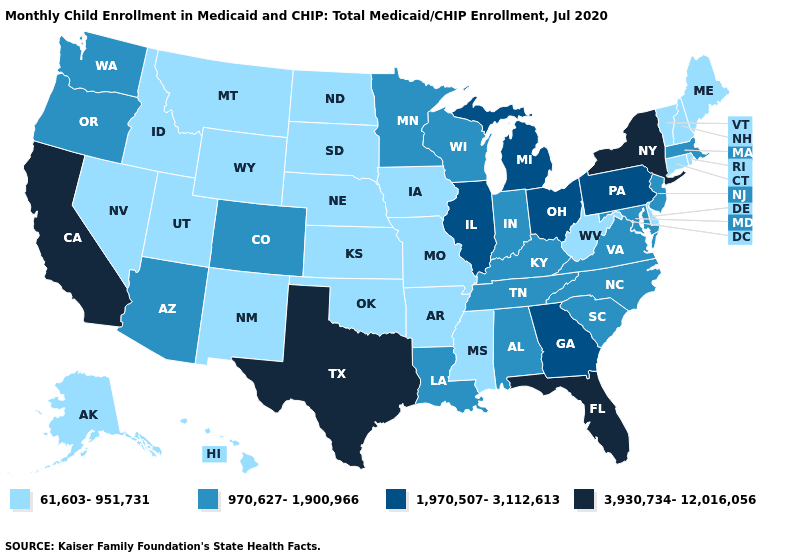What is the highest value in the USA?
Concise answer only. 3,930,734-12,016,056. What is the highest value in states that border West Virginia?
Answer briefly. 1,970,507-3,112,613. What is the value of Georgia?
Concise answer only. 1,970,507-3,112,613. What is the value of Wyoming?
Write a very short answer. 61,603-951,731. Does New Mexico have the lowest value in the USA?
Concise answer only. Yes. Name the states that have a value in the range 61,603-951,731?
Short answer required. Alaska, Arkansas, Connecticut, Delaware, Hawaii, Idaho, Iowa, Kansas, Maine, Mississippi, Missouri, Montana, Nebraska, Nevada, New Hampshire, New Mexico, North Dakota, Oklahoma, Rhode Island, South Dakota, Utah, Vermont, West Virginia, Wyoming. What is the value of Washington?
Short answer required. 970,627-1,900,966. Name the states that have a value in the range 970,627-1,900,966?
Be succinct. Alabama, Arizona, Colorado, Indiana, Kentucky, Louisiana, Maryland, Massachusetts, Minnesota, New Jersey, North Carolina, Oregon, South Carolina, Tennessee, Virginia, Washington, Wisconsin. What is the highest value in the USA?
Keep it brief. 3,930,734-12,016,056. What is the value of Oregon?
Answer briefly. 970,627-1,900,966. Does Iowa have the lowest value in the MidWest?
Keep it brief. Yes. Name the states that have a value in the range 1,970,507-3,112,613?
Give a very brief answer. Georgia, Illinois, Michigan, Ohio, Pennsylvania. What is the lowest value in states that border Pennsylvania?
Short answer required. 61,603-951,731. Name the states that have a value in the range 61,603-951,731?
Be succinct. Alaska, Arkansas, Connecticut, Delaware, Hawaii, Idaho, Iowa, Kansas, Maine, Mississippi, Missouri, Montana, Nebraska, Nevada, New Hampshire, New Mexico, North Dakota, Oklahoma, Rhode Island, South Dakota, Utah, Vermont, West Virginia, Wyoming. Name the states that have a value in the range 61,603-951,731?
Short answer required. Alaska, Arkansas, Connecticut, Delaware, Hawaii, Idaho, Iowa, Kansas, Maine, Mississippi, Missouri, Montana, Nebraska, Nevada, New Hampshire, New Mexico, North Dakota, Oklahoma, Rhode Island, South Dakota, Utah, Vermont, West Virginia, Wyoming. 